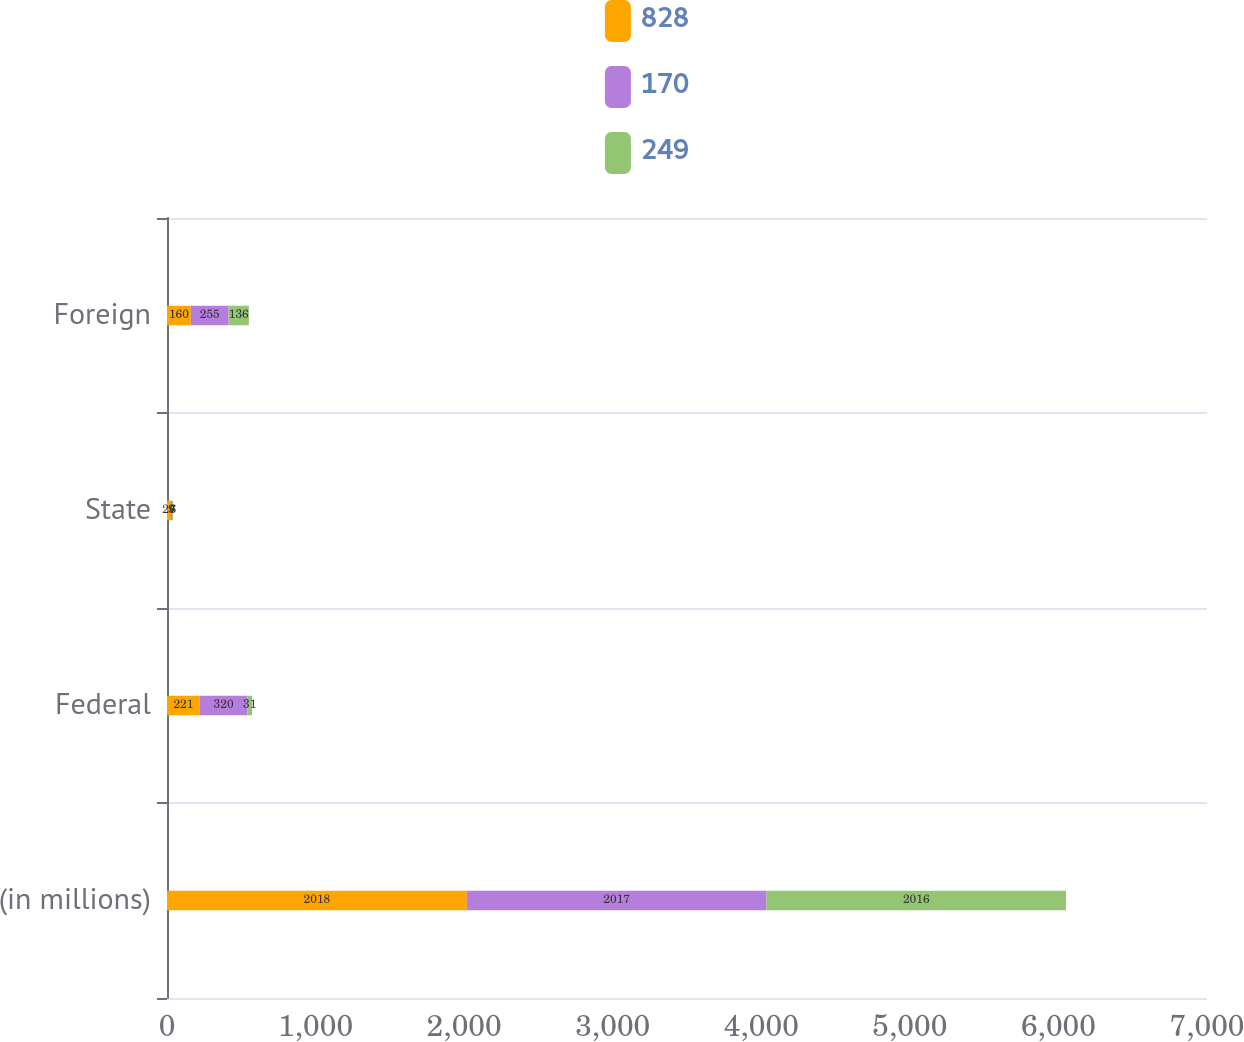Convert chart to OTSL. <chart><loc_0><loc_0><loc_500><loc_500><stacked_bar_chart><ecel><fcel>(in millions)<fcel>Federal<fcel>State<fcel>Foreign<nl><fcel>828<fcel>2018<fcel>221<fcel>27<fcel>160<nl><fcel>170<fcel>2017<fcel>320<fcel>9<fcel>255<nl><fcel>249<fcel>2016<fcel>31<fcel>6<fcel>136<nl></chart> 